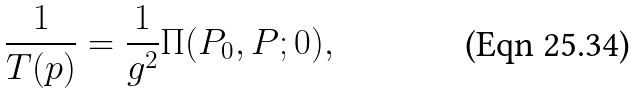<formula> <loc_0><loc_0><loc_500><loc_500>\frac { 1 } { T ( p ) } = \frac { 1 } { g ^ { 2 } } \Pi ( P _ { 0 } , P ; 0 ) ,</formula> 